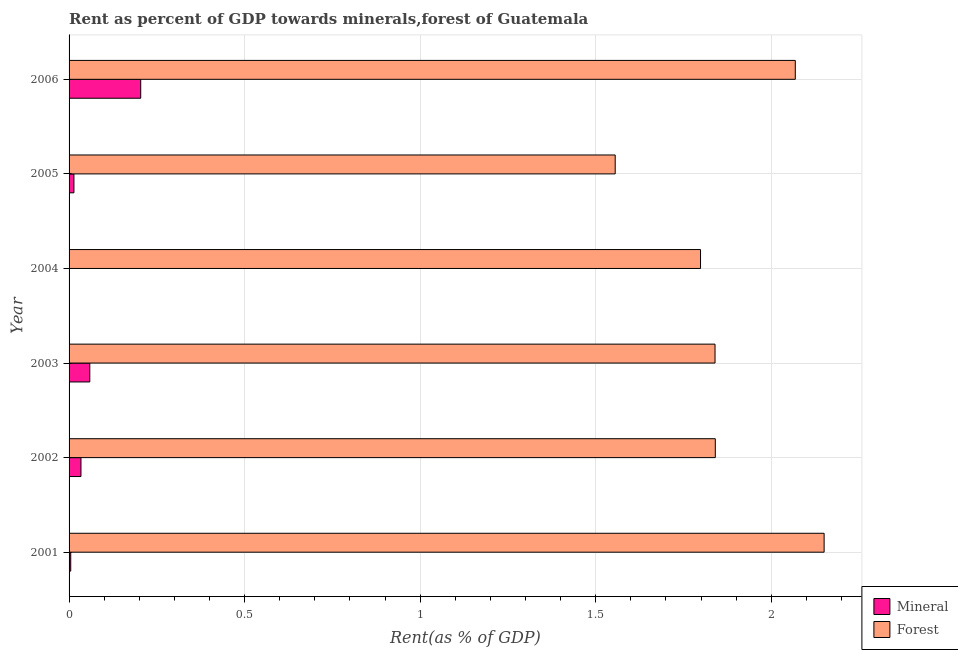How many different coloured bars are there?
Provide a short and direct response. 2. Are the number of bars per tick equal to the number of legend labels?
Provide a short and direct response. Yes. How many bars are there on the 5th tick from the top?
Provide a short and direct response. 2. In how many cases, is the number of bars for a given year not equal to the number of legend labels?
Give a very brief answer. 0. What is the forest rent in 2006?
Make the answer very short. 2.07. Across all years, what is the maximum mineral rent?
Keep it short and to the point. 0.2. Across all years, what is the minimum mineral rent?
Offer a very short reply. 0. In which year was the mineral rent minimum?
Your answer should be very brief. 2004. What is the total mineral rent in the graph?
Your answer should be very brief. 0.32. What is the difference between the mineral rent in 2002 and that in 2006?
Your answer should be compact. -0.17. What is the difference between the forest rent in 2004 and the mineral rent in 2006?
Make the answer very short. 1.59. What is the average forest rent per year?
Make the answer very short. 1.88. In the year 2005, what is the difference between the mineral rent and forest rent?
Your response must be concise. -1.54. What is the ratio of the mineral rent in 2003 to that in 2005?
Provide a short and direct response. 4.27. What is the difference between the highest and the second highest mineral rent?
Offer a very short reply. 0.14. In how many years, is the forest rent greater than the average forest rent taken over all years?
Ensure brevity in your answer.  2. What does the 1st bar from the top in 2001 represents?
Offer a very short reply. Forest. What does the 1st bar from the bottom in 2002 represents?
Your response must be concise. Mineral. How many bars are there?
Make the answer very short. 12. Are all the bars in the graph horizontal?
Your answer should be very brief. Yes. Are the values on the major ticks of X-axis written in scientific E-notation?
Provide a short and direct response. No. Does the graph contain any zero values?
Your answer should be very brief. No. How many legend labels are there?
Provide a succinct answer. 2. How are the legend labels stacked?
Your answer should be compact. Vertical. What is the title of the graph?
Offer a very short reply. Rent as percent of GDP towards minerals,forest of Guatemala. What is the label or title of the X-axis?
Your answer should be very brief. Rent(as % of GDP). What is the Rent(as % of GDP) of Mineral in 2001?
Your answer should be compact. 0. What is the Rent(as % of GDP) of Forest in 2001?
Your response must be concise. 2.15. What is the Rent(as % of GDP) of Mineral in 2002?
Ensure brevity in your answer.  0.03. What is the Rent(as % of GDP) of Forest in 2002?
Provide a succinct answer. 1.84. What is the Rent(as % of GDP) in Mineral in 2003?
Ensure brevity in your answer.  0.06. What is the Rent(as % of GDP) in Forest in 2003?
Your response must be concise. 1.84. What is the Rent(as % of GDP) in Mineral in 2004?
Your answer should be compact. 0. What is the Rent(as % of GDP) of Forest in 2004?
Your response must be concise. 1.8. What is the Rent(as % of GDP) of Mineral in 2005?
Keep it short and to the point. 0.01. What is the Rent(as % of GDP) of Forest in 2005?
Provide a short and direct response. 1.56. What is the Rent(as % of GDP) in Mineral in 2006?
Provide a succinct answer. 0.2. What is the Rent(as % of GDP) of Forest in 2006?
Provide a succinct answer. 2.07. Across all years, what is the maximum Rent(as % of GDP) of Mineral?
Offer a very short reply. 0.2. Across all years, what is the maximum Rent(as % of GDP) in Forest?
Give a very brief answer. 2.15. Across all years, what is the minimum Rent(as % of GDP) of Mineral?
Offer a terse response. 0. Across all years, what is the minimum Rent(as % of GDP) in Forest?
Give a very brief answer. 1.56. What is the total Rent(as % of GDP) in Mineral in the graph?
Make the answer very short. 0.32. What is the total Rent(as % of GDP) in Forest in the graph?
Provide a short and direct response. 11.25. What is the difference between the Rent(as % of GDP) of Mineral in 2001 and that in 2002?
Ensure brevity in your answer.  -0.03. What is the difference between the Rent(as % of GDP) of Forest in 2001 and that in 2002?
Your answer should be compact. 0.31. What is the difference between the Rent(as % of GDP) in Mineral in 2001 and that in 2003?
Offer a very short reply. -0.05. What is the difference between the Rent(as % of GDP) in Forest in 2001 and that in 2003?
Give a very brief answer. 0.31. What is the difference between the Rent(as % of GDP) in Mineral in 2001 and that in 2004?
Provide a succinct answer. 0. What is the difference between the Rent(as % of GDP) of Forest in 2001 and that in 2004?
Offer a very short reply. 0.35. What is the difference between the Rent(as % of GDP) of Mineral in 2001 and that in 2005?
Ensure brevity in your answer.  -0.01. What is the difference between the Rent(as % of GDP) in Forest in 2001 and that in 2005?
Offer a terse response. 0.6. What is the difference between the Rent(as % of GDP) in Mineral in 2001 and that in 2006?
Your response must be concise. -0.2. What is the difference between the Rent(as % of GDP) of Forest in 2001 and that in 2006?
Your response must be concise. 0.08. What is the difference between the Rent(as % of GDP) of Mineral in 2002 and that in 2003?
Offer a very short reply. -0.03. What is the difference between the Rent(as % of GDP) in Forest in 2002 and that in 2003?
Offer a terse response. 0. What is the difference between the Rent(as % of GDP) in Mineral in 2002 and that in 2004?
Make the answer very short. 0.03. What is the difference between the Rent(as % of GDP) of Forest in 2002 and that in 2004?
Keep it short and to the point. 0.04. What is the difference between the Rent(as % of GDP) of Mineral in 2002 and that in 2005?
Provide a succinct answer. 0.02. What is the difference between the Rent(as % of GDP) of Forest in 2002 and that in 2005?
Make the answer very short. 0.29. What is the difference between the Rent(as % of GDP) in Mineral in 2002 and that in 2006?
Provide a succinct answer. -0.17. What is the difference between the Rent(as % of GDP) of Forest in 2002 and that in 2006?
Make the answer very short. -0.23. What is the difference between the Rent(as % of GDP) in Mineral in 2003 and that in 2004?
Provide a short and direct response. 0.06. What is the difference between the Rent(as % of GDP) in Forest in 2003 and that in 2004?
Provide a short and direct response. 0.04. What is the difference between the Rent(as % of GDP) in Mineral in 2003 and that in 2005?
Keep it short and to the point. 0.05. What is the difference between the Rent(as % of GDP) of Forest in 2003 and that in 2005?
Keep it short and to the point. 0.28. What is the difference between the Rent(as % of GDP) of Mineral in 2003 and that in 2006?
Offer a very short reply. -0.14. What is the difference between the Rent(as % of GDP) of Forest in 2003 and that in 2006?
Give a very brief answer. -0.23. What is the difference between the Rent(as % of GDP) of Mineral in 2004 and that in 2005?
Offer a terse response. -0.01. What is the difference between the Rent(as % of GDP) of Forest in 2004 and that in 2005?
Your answer should be very brief. 0.24. What is the difference between the Rent(as % of GDP) in Mineral in 2004 and that in 2006?
Offer a very short reply. -0.2. What is the difference between the Rent(as % of GDP) in Forest in 2004 and that in 2006?
Your response must be concise. -0.27. What is the difference between the Rent(as % of GDP) of Mineral in 2005 and that in 2006?
Ensure brevity in your answer.  -0.19. What is the difference between the Rent(as % of GDP) in Forest in 2005 and that in 2006?
Give a very brief answer. -0.51. What is the difference between the Rent(as % of GDP) of Mineral in 2001 and the Rent(as % of GDP) of Forest in 2002?
Your answer should be compact. -1.84. What is the difference between the Rent(as % of GDP) in Mineral in 2001 and the Rent(as % of GDP) in Forest in 2003?
Ensure brevity in your answer.  -1.84. What is the difference between the Rent(as % of GDP) in Mineral in 2001 and the Rent(as % of GDP) in Forest in 2004?
Your answer should be compact. -1.79. What is the difference between the Rent(as % of GDP) in Mineral in 2001 and the Rent(as % of GDP) in Forest in 2005?
Provide a short and direct response. -1.55. What is the difference between the Rent(as % of GDP) of Mineral in 2001 and the Rent(as % of GDP) of Forest in 2006?
Give a very brief answer. -2.06. What is the difference between the Rent(as % of GDP) of Mineral in 2002 and the Rent(as % of GDP) of Forest in 2003?
Give a very brief answer. -1.81. What is the difference between the Rent(as % of GDP) in Mineral in 2002 and the Rent(as % of GDP) in Forest in 2004?
Offer a very short reply. -1.76. What is the difference between the Rent(as % of GDP) in Mineral in 2002 and the Rent(as % of GDP) in Forest in 2005?
Provide a short and direct response. -1.52. What is the difference between the Rent(as % of GDP) of Mineral in 2002 and the Rent(as % of GDP) of Forest in 2006?
Your answer should be very brief. -2.03. What is the difference between the Rent(as % of GDP) in Mineral in 2003 and the Rent(as % of GDP) in Forest in 2004?
Offer a very short reply. -1.74. What is the difference between the Rent(as % of GDP) in Mineral in 2003 and the Rent(as % of GDP) in Forest in 2005?
Offer a very short reply. -1.5. What is the difference between the Rent(as % of GDP) in Mineral in 2003 and the Rent(as % of GDP) in Forest in 2006?
Offer a very short reply. -2.01. What is the difference between the Rent(as % of GDP) of Mineral in 2004 and the Rent(as % of GDP) of Forest in 2005?
Your response must be concise. -1.56. What is the difference between the Rent(as % of GDP) in Mineral in 2004 and the Rent(as % of GDP) in Forest in 2006?
Offer a very short reply. -2.07. What is the difference between the Rent(as % of GDP) in Mineral in 2005 and the Rent(as % of GDP) in Forest in 2006?
Provide a succinct answer. -2.05. What is the average Rent(as % of GDP) of Mineral per year?
Give a very brief answer. 0.05. What is the average Rent(as % of GDP) in Forest per year?
Your answer should be very brief. 1.88. In the year 2001, what is the difference between the Rent(as % of GDP) of Mineral and Rent(as % of GDP) of Forest?
Your answer should be very brief. -2.15. In the year 2002, what is the difference between the Rent(as % of GDP) of Mineral and Rent(as % of GDP) of Forest?
Ensure brevity in your answer.  -1.81. In the year 2003, what is the difference between the Rent(as % of GDP) of Mineral and Rent(as % of GDP) of Forest?
Your answer should be compact. -1.78. In the year 2004, what is the difference between the Rent(as % of GDP) in Mineral and Rent(as % of GDP) in Forest?
Provide a short and direct response. -1.8. In the year 2005, what is the difference between the Rent(as % of GDP) in Mineral and Rent(as % of GDP) in Forest?
Make the answer very short. -1.54. In the year 2006, what is the difference between the Rent(as % of GDP) in Mineral and Rent(as % of GDP) in Forest?
Provide a succinct answer. -1.86. What is the ratio of the Rent(as % of GDP) in Mineral in 2001 to that in 2002?
Your answer should be compact. 0.14. What is the ratio of the Rent(as % of GDP) in Forest in 2001 to that in 2002?
Give a very brief answer. 1.17. What is the ratio of the Rent(as % of GDP) in Mineral in 2001 to that in 2003?
Your response must be concise. 0.08. What is the ratio of the Rent(as % of GDP) in Forest in 2001 to that in 2003?
Offer a terse response. 1.17. What is the ratio of the Rent(as % of GDP) in Mineral in 2001 to that in 2004?
Provide a succinct answer. 44.02. What is the ratio of the Rent(as % of GDP) in Forest in 2001 to that in 2004?
Your response must be concise. 1.2. What is the ratio of the Rent(as % of GDP) in Mineral in 2001 to that in 2005?
Keep it short and to the point. 0.34. What is the ratio of the Rent(as % of GDP) of Forest in 2001 to that in 2005?
Provide a succinct answer. 1.38. What is the ratio of the Rent(as % of GDP) of Mineral in 2001 to that in 2006?
Give a very brief answer. 0.02. What is the ratio of the Rent(as % of GDP) of Forest in 2001 to that in 2006?
Your response must be concise. 1.04. What is the ratio of the Rent(as % of GDP) in Mineral in 2002 to that in 2003?
Make the answer very short. 0.57. What is the ratio of the Rent(as % of GDP) in Forest in 2002 to that in 2003?
Make the answer very short. 1. What is the ratio of the Rent(as % of GDP) of Mineral in 2002 to that in 2004?
Ensure brevity in your answer.  313.39. What is the ratio of the Rent(as % of GDP) of Forest in 2002 to that in 2004?
Offer a very short reply. 1.02. What is the ratio of the Rent(as % of GDP) of Mineral in 2002 to that in 2005?
Make the answer very short. 2.45. What is the ratio of the Rent(as % of GDP) of Forest in 2002 to that in 2005?
Provide a succinct answer. 1.18. What is the ratio of the Rent(as % of GDP) of Mineral in 2002 to that in 2006?
Ensure brevity in your answer.  0.17. What is the ratio of the Rent(as % of GDP) in Forest in 2002 to that in 2006?
Provide a short and direct response. 0.89. What is the ratio of the Rent(as % of GDP) of Mineral in 2003 to that in 2004?
Your answer should be compact. 546.33. What is the ratio of the Rent(as % of GDP) of Mineral in 2003 to that in 2005?
Offer a very short reply. 4.27. What is the ratio of the Rent(as % of GDP) in Forest in 2003 to that in 2005?
Offer a terse response. 1.18. What is the ratio of the Rent(as % of GDP) of Mineral in 2003 to that in 2006?
Your response must be concise. 0.29. What is the ratio of the Rent(as % of GDP) in Forest in 2003 to that in 2006?
Ensure brevity in your answer.  0.89. What is the ratio of the Rent(as % of GDP) in Mineral in 2004 to that in 2005?
Offer a terse response. 0.01. What is the ratio of the Rent(as % of GDP) in Forest in 2004 to that in 2005?
Offer a terse response. 1.16. What is the ratio of the Rent(as % of GDP) of Mineral in 2004 to that in 2006?
Your response must be concise. 0. What is the ratio of the Rent(as % of GDP) in Forest in 2004 to that in 2006?
Your answer should be very brief. 0.87. What is the ratio of the Rent(as % of GDP) of Mineral in 2005 to that in 2006?
Your answer should be very brief. 0.07. What is the ratio of the Rent(as % of GDP) in Forest in 2005 to that in 2006?
Offer a very short reply. 0.75. What is the difference between the highest and the second highest Rent(as % of GDP) in Mineral?
Offer a terse response. 0.14. What is the difference between the highest and the second highest Rent(as % of GDP) of Forest?
Offer a very short reply. 0.08. What is the difference between the highest and the lowest Rent(as % of GDP) of Mineral?
Ensure brevity in your answer.  0.2. What is the difference between the highest and the lowest Rent(as % of GDP) in Forest?
Your answer should be very brief. 0.6. 